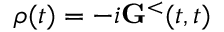Convert formula to latex. <formula><loc_0><loc_0><loc_500><loc_500>\rho ( t ) = - i { G } ^ { < } ( t , t )</formula> 